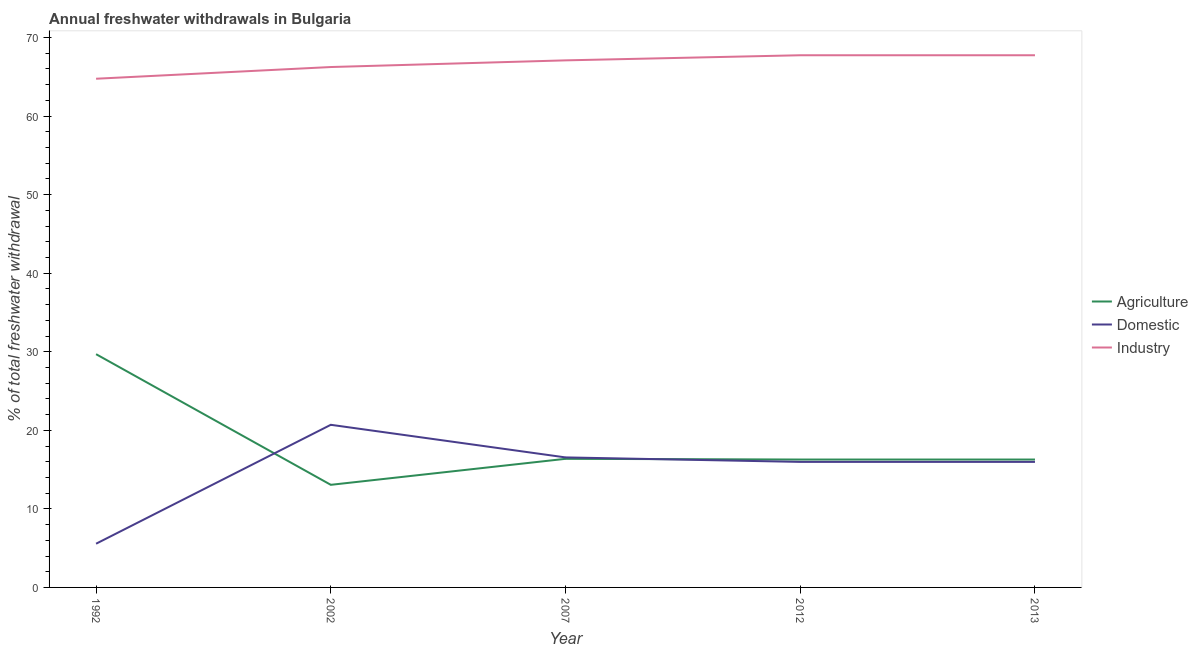How many different coloured lines are there?
Offer a terse response. 3. What is the percentage of freshwater withdrawal for industry in 2013?
Your response must be concise. 67.74. Across all years, what is the maximum percentage of freshwater withdrawal for industry?
Keep it short and to the point. 67.74. Across all years, what is the minimum percentage of freshwater withdrawal for agriculture?
Give a very brief answer. 13.06. In which year was the percentage of freshwater withdrawal for agriculture maximum?
Provide a short and direct response. 1992. In which year was the percentage of freshwater withdrawal for industry minimum?
Your response must be concise. 1992. What is the total percentage of freshwater withdrawal for industry in the graph?
Provide a short and direct response. 333.56. What is the difference between the percentage of freshwater withdrawal for agriculture in 1992 and that in 2002?
Provide a succinct answer. 16.63. What is the difference between the percentage of freshwater withdrawal for industry in 2013 and the percentage of freshwater withdrawal for domestic purposes in 2007?
Your answer should be very brief. 51.19. What is the average percentage of freshwater withdrawal for domestic purposes per year?
Provide a succinct answer. 14.95. In the year 2012, what is the difference between the percentage of freshwater withdrawal for industry and percentage of freshwater withdrawal for domestic purposes?
Make the answer very short. 51.76. In how many years, is the percentage of freshwater withdrawal for domestic purposes greater than 32 %?
Offer a very short reply. 0. What is the ratio of the percentage of freshwater withdrawal for industry in 2007 to that in 2012?
Your response must be concise. 0.99. Is the percentage of freshwater withdrawal for domestic purposes in 2007 less than that in 2013?
Your answer should be very brief. No. Is the difference between the percentage of freshwater withdrawal for industry in 2002 and 2012 greater than the difference between the percentage of freshwater withdrawal for domestic purposes in 2002 and 2012?
Your response must be concise. No. What is the difference between the highest and the second highest percentage of freshwater withdrawal for industry?
Offer a very short reply. 0. What is the difference between the highest and the lowest percentage of freshwater withdrawal for agriculture?
Make the answer very short. 16.63. Is it the case that in every year, the sum of the percentage of freshwater withdrawal for agriculture and percentage of freshwater withdrawal for domestic purposes is greater than the percentage of freshwater withdrawal for industry?
Offer a terse response. No. Is the percentage of freshwater withdrawal for industry strictly less than the percentage of freshwater withdrawal for agriculture over the years?
Make the answer very short. No. How many lines are there?
Your answer should be very brief. 3. How many years are there in the graph?
Your answer should be very brief. 5. What is the difference between two consecutive major ticks on the Y-axis?
Offer a very short reply. 10. How many legend labels are there?
Provide a succinct answer. 3. What is the title of the graph?
Make the answer very short. Annual freshwater withdrawals in Bulgaria. What is the label or title of the Y-axis?
Make the answer very short. % of total freshwater withdrawal. What is the % of total freshwater withdrawal in Agriculture in 1992?
Provide a succinct answer. 29.69. What is the % of total freshwater withdrawal in Domestic in 1992?
Provide a short and direct response. 5.56. What is the % of total freshwater withdrawal in Industry in 1992?
Ensure brevity in your answer.  64.75. What is the % of total freshwater withdrawal in Agriculture in 2002?
Your answer should be very brief. 13.06. What is the % of total freshwater withdrawal in Domestic in 2002?
Give a very brief answer. 20.7. What is the % of total freshwater withdrawal of Industry in 2002?
Offer a terse response. 66.24. What is the % of total freshwater withdrawal of Agriculture in 2007?
Keep it short and to the point. 16.37. What is the % of total freshwater withdrawal of Domestic in 2007?
Provide a succinct answer. 16.55. What is the % of total freshwater withdrawal of Industry in 2007?
Your answer should be very brief. 67.09. What is the % of total freshwater withdrawal in Agriculture in 2012?
Keep it short and to the point. 16.28. What is the % of total freshwater withdrawal in Domestic in 2012?
Your answer should be compact. 15.98. What is the % of total freshwater withdrawal in Industry in 2012?
Give a very brief answer. 67.74. What is the % of total freshwater withdrawal in Agriculture in 2013?
Your answer should be compact. 16.28. What is the % of total freshwater withdrawal in Domestic in 2013?
Provide a succinct answer. 15.98. What is the % of total freshwater withdrawal in Industry in 2013?
Give a very brief answer. 67.74. Across all years, what is the maximum % of total freshwater withdrawal of Agriculture?
Your response must be concise. 29.69. Across all years, what is the maximum % of total freshwater withdrawal of Domestic?
Provide a succinct answer. 20.7. Across all years, what is the maximum % of total freshwater withdrawal in Industry?
Your response must be concise. 67.74. Across all years, what is the minimum % of total freshwater withdrawal of Agriculture?
Offer a terse response. 13.06. Across all years, what is the minimum % of total freshwater withdrawal of Domestic?
Your answer should be very brief. 5.56. Across all years, what is the minimum % of total freshwater withdrawal in Industry?
Give a very brief answer. 64.75. What is the total % of total freshwater withdrawal in Agriculture in the graph?
Offer a very short reply. 91.68. What is the total % of total freshwater withdrawal of Domestic in the graph?
Ensure brevity in your answer.  74.77. What is the total % of total freshwater withdrawal in Industry in the graph?
Give a very brief answer. 333.56. What is the difference between the % of total freshwater withdrawal of Agriculture in 1992 and that in 2002?
Ensure brevity in your answer.  16.63. What is the difference between the % of total freshwater withdrawal of Domestic in 1992 and that in 2002?
Keep it short and to the point. -15.14. What is the difference between the % of total freshwater withdrawal in Industry in 1992 and that in 2002?
Offer a terse response. -1.49. What is the difference between the % of total freshwater withdrawal of Agriculture in 1992 and that in 2007?
Keep it short and to the point. 13.32. What is the difference between the % of total freshwater withdrawal in Domestic in 1992 and that in 2007?
Your response must be concise. -10.99. What is the difference between the % of total freshwater withdrawal of Industry in 1992 and that in 2007?
Ensure brevity in your answer.  -2.34. What is the difference between the % of total freshwater withdrawal of Agriculture in 1992 and that in 2012?
Your response must be concise. 13.41. What is the difference between the % of total freshwater withdrawal in Domestic in 1992 and that in 2012?
Offer a very short reply. -10.42. What is the difference between the % of total freshwater withdrawal in Industry in 1992 and that in 2012?
Keep it short and to the point. -2.99. What is the difference between the % of total freshwater withdrawal in Agriculture in 1992 and that in 2013?
Ensure brevity in your answer.  13.41. What is the difference between the % of total freshwater withdrawal of Domestic in 1992 and that in 2013?
Your response must be concise. -10.42. What is the difference between the % of total freshwater withdrawal in Industry in 1992 and that in 2013?
Provide a succinct answer. -2.99. What is the difference between the % of total freshwater withdrawal in Agriculture in 2002 and that in 2007?
Provide a succinct answer. -3.31. What is the difference between the % of total freshwater withdrawal of Domestic in 2002 and that in 2007?
Ensure brevity in your answer.  4.15. What is the difference between the % of total freshwater withdrawal of Industry in 2002 and that in 2007?
Offer a very short reply. -0.85. What is the difference between the % of total freshwater withdrawal in Agriculture in 2002 and that in 2012?
Provide a short and direct response. -3.22. What is the difference between the % of total freshwater withdrawal of Domestic in 2002 and that in 2012?
Your response must be concise. 4.72. What is the difference between the % of total freshwater withdrawal of Industry in 2002 and that in 2012?
Your response must be concise. -1.5. What is the difference between the % of total freshwater withdrawal in Agriculture in 2002 and that in 2013?
Your answer should be very brief. -3.22. What is the difference between the % of total freshwater withdrawal of Domestic in 2002 and that in 2013?
Your answer should be compact. 4.72. What is the difference between the % of total freshwater withdrawal in Agriculture in 2007 and that in 2012?
Make the answer very short. 0.09. What is the difference between the % of total freshwater withdrawal of Domestic in 2007 and that in 2012?
Make the answer very short. 0.57. What is the difference between the % of total freshwater withdrawal of Industry in 2007 and that in 2012?
Provide a succinct answer. -0.65. What is the difference between the % of total freshwater withdrawal in Agriculture in 2007 and that in 2013?
Make the answer very short. 0.09. What is the difference between the % of total freshwater withdrawal of Domestic in 2007 and that in 2013?
Keep it short and to the point. 0.57. What is the difference between the % of total freshwater withdrawal of Industry in 2007 and that in 2013?
Your answer should be compact. -0.65. What is the difference between the % of total freshwater withdrawal in Agriculture in 1992 and the % of total freshwater withdrawal in Domestic in 2002?
Keep it short and to the point. 8.99. What is the difference between the % of total freshwater withdrawal of Agriculture in 1992 and the % of total freshwater withdrawal of Industry in 2002?
Your response must be concise. -36.55. What is the difference between the % of total freshwater withdrawal in Domestic in 1992 and the % of total freshwater withdrawal in Industry in 2002?
Keep it short and to the point. -60.68. What is the difference between the % of total freshwater withdrawal of Agriculture in 1992 and the % of total freshwater withdrawal of Domestic in 2007?
Provide a succinct answer. 13.14. What is the difference between the % of total freshwater withdrawal in Agriculture in 1992 and the % of total freshwater withdrawal in Industry in 2007?
Make the answer very short. -37.4. What is the difference between the % of total freshwater withdrawal in Domestic in 1992 and the % of total freshwater withdrawal in Industry in 2007?
Your answer should be compact. -61.53. What is the difference between the % of total freshwater withdrawal in Agriculture in 1992 and the % of total freshwater withdrawal in Domestic in 2012?
Keep it short and to the point. 13.71. What is the difference between the % of total freshwater withdrawal of Agriculture in 1992 and the % of total freshwater withdrawal of Industry in 2012?
Provide a short and direct response. -38.05. What is the difference between the % of total freshwater withdrawal of Domestic in 1992 and the % of total freshwater withdrawal of Industry in 2012?
Give a very brief answer. -62.18. What is the difference between the % of total freshwater withdrawal in Agriculture in 1992 and the % of total freshwater withdrawal in Domestic in 2013?
Make the answer very short. 13.71. What is the difference between the % of total freshwater withdrawal in Agriculture in 1992 and the % of total freshwater withdrawal in Industry in 2013?
Offer a very short reply. -38.05. What is the difference between the % of total freshwater withdrawal of Domestic in 1992 and the % of total freshwater withdrawal of Industry in 2013?
Provide a short and direct response. -62.18. What is the difference between the % of total freshwater withdrawal in Agriculture in 2002 and the % of total freshwater withdrawal in Domestic in 2007?
Your response must be concise. -3.49. What is the difference between the % of total freshwater withdrawal of Agriculture in 2002 and the % of total freshwater withdrawal of Industry in 2007?
Offer a terse response. -54.03. What is the difference between the % of total freshwater withdrawal in Domestic in 2002 and the % of total freshwater withdrawal in Industry in 2007?
Give a very brief answer. -46.39. What is the difference between the % of total freshwater withdrawal in Agriculture in 2002 and the % of total freshwater withdrawal in Domestic in 2012?
Provide a short and direct response. -2.92. What is the difference between the % of total freshwater withdrawal in Agriculture in 2002 and the % of total freshwater withdrawal in Industry in 2012?
Ensure brevity in your answer.  -54.68. What is the difference between the % of total freshwater withdrawal in Domestic in 2002 and the % of total freshwater withdrawal in Industry in 2012?
Keep it short and to the point. -47.04. What is the difference between the % of total freshwater withdrawal of Agriculture in 2002 and the % of total freshwater withdrawal of Domestic in 2013?
Make the answer very short. -2.92. What is the difference between the % of total freshwater withdrawal of Agriculture in 2002 and the % of total freshwater withdrawal of Industry in 2013?
Offer a terse response. -54.68. What is the difference between the % of total freshwater withdrawal of Domestic in 2002 and the % of total freshwater withdrawal of Industry in 2013?
Make the answer very short. -47.04. What is the difference between the % of total freshwater withdrawal in Agriculture in 2007 and the % of total freshwater withdrawal in Domestic in 2012?
Provide a succinct answer. 0.39. What is the difference between the % of total freshwater withdrawal in Agriculture in 2007 and the % of total freshwater withdrawal in Industry in 2012?
Provide a short and direct response. -51.37. What is the difference between the % of total freshwater withdrawal of Domestic in 2007 and the % of total freshwater withdrawal of Industry in 2012?
Provide a succinct answer. -51.19. What is the difference between the % of total freshwater withdrawal of Agriculture in 2007 and the % of total freshwater withdrawal of Domestic in 2013?
Give a very brief answer. 0.39. What is the difference between the % of total freshwater withdrawal of Agriculture in 2007 and the % of total freshwater withdrawal of Industry in 2013?
Your answer should be very brief. -51.37. What is the difference between the % of total freshwater withdrawal of Domestic in 2007 and the % of total freshwater withdrawal of Industry in 2013?
Offer a very short reply. -51.19. What is the difference between the % of total freshwater withdrawal in Agriculture in 2012 and the % of total freshwater withdrawal in Industry in 2013?
Provide a succinct answer. -51.46. What is the difference between the % of total freshwater withdrawal in Domestic in 2012 and the % of total freshwater withdrawal in Industry in 2013?
Offer a very short reply. -51.76. What is the average % of total freshwater withdrawal of Agriculture per year?
Provide a short and direct response. 18.34. What is the average % of total freshwater withdrawal of Domestic per year?
Ensure brevity in your answer.  14.95. What is the average % of total freshwater withdrawal in Industry per year?
Provide a short and direct response. 66.71. In the year 1992, what is the difference between the % of total freshwater withdrawal of Agriculture and % of total freshwater withdrawal of Domestic?
Give a very brief answer. 24.13. In the year 1992, what is the difference between the % of total freshwater withdrawal of Agriculture and % of total freshwater withdrawal of Industry?
Keep it short and to the point. -35.06. In the year 1992, what is the difference between the % of total freshwater withdrawal of Domestic and % of total freshwater withdrawal of Industry?
Your answer should be very brief. -59.19. In the year 2002, what is the difference between the % of total freshwater withdrawal of Agriculture and % of total freshwater withdrawal of Domestic?
Your response must be concise. -7.64. In the year 2002, what is the difference between the % of total freshwater withdrawal in Agriculture and % of total freshwater withdrawal in Industry?
Your answer should be very brief. -53.18. In the year 2002, what is the difference between the % of total freshwater withdrawal of Domestic and % of total freshwater withdrawal of Industry?
Keep it short and to the point. -45.54. In the year 2007, what is the difference between the % of total freshwater withdrawal of Agriculture and % of total freshwater withdrawal of Domestic?
Provide a succinct answer. -0.18. In the year 2007, what is the difference between the % of total freshwater withdrawal of Agriculture and % of total freshwater withdrawal of Industry?
Keep it short and to the point. -50.72. In the year 2007, what is the difference between the % of total freshwater withdrawal in Domestic and % of total freshwater withdrawal in Industry?
Keep it short and to the point. -50.54. In the year 2012, what is the difference between the % of total freshwater withdrawal in Agriculture and % of total freshwater withdrawal in Industry?
Keep it short and to the point. -51.46. In the year 2012, what is the difference between the % of total freshwater withdrawal in Domestic and % of total freshwater withdrawal in Industry?
Provide a short and direct response. -51.76. In the year 2013, what is the difference between the % of total freshwater withdrawal in Agriculture and % of total freshwater withdrawal in Domestic?
Your answer should be compact. 0.3. In the year 2013, what is the difference between the % of total freshwater withdrawal of Agriculture and % of total freshwater withdrawal of Industry?
Your response must be concise. -51.46. In the year 2013, what is the difference between the % of total freshwater withdrawal in Domestic and % of total freshwater withdrawal in Industry?
Provide a short and direct response. -51.76. What is the ratio of the % of total freshwater withdrawal in Agriculture in 1992 to that in 2002?
Ensure brevity in your answer.  2.27. What is the ratio of the % of total freshwater withdrawal of Domestic in 1992 to that in 2002?
Keep it short and to the point. 0.27. What is the ratio of the % of total freshwater withdrawal of Industry in 1992 to that in 2002?
Make the answer very short. 0.98. What is the ratio of the % of total freshwater withdrawal in Agriculture in 1992 to that in 2007?
Provide a short and direct response. 1.81. What is the ratio of the % of total freshwater withdrawal in Domestic in 1992 to that in 2007?
Keep it short and to the point. 0.34. What is the ratio of the % of total freshwater withdrawal in Industry in 1992 to that in 2007?
Make the answer very short. 0.97. What is the ratio of the % of total freshwater withdrawal in Agriculture in 1992 to that in 2012?
Ensure brevity in your answer.  1.82. What is the ratio of the % of total freshwater withdrawal of Domestic in 1992 to that in 2012?
Give a very brief answer. 0.35. What is the ratio of the % of total freshwater withdrawal of Industry in 1992 to that in 2012?
Offer a terse response. 0.96. What is the ratio of the % of total freshwater withdrawal in Agriculture in 1992 to that in 2013?
Make the answer very short. 1.82. What is the ratio of the % of total freshwater withdrawal of Domestic in 1992 to that in 2013?
Your answer should be compact. 0.35. What is the ratio of the % of total freshwater withdrawal in Industry in 1992 to that in 2013?
Provide a short and direct response. 0.96. What is the ratio of the % of total freshwater withdrawal in Agriculture in 2002 to that in 2007?
Make the answer very short. 0.8. What is the ratio of the % of total freshwater withdrawal in Domestic in 2002 to that in 2007?
Offer a terse response. 1.25. What is the ratio of the % of total freshwater withdrawal of Industry in 2002 to that in 2007?
Offer a very short reply. 0.99. What is the ratio of the % of total freshwater withdrawal in Agriculture in 2002 to that in 2012?
Keep it short and to the point. 0.8. What is the ratio of the % of total freshwater withdrawal in Domestic in 2002 to that in 2012?
Provide a short and direct response. 1.3. What is the ratio of the % of total freshwater withdrawal of Industry in 2002 to that in 2012?
Offer a very short reply. 0.98. What is the ratio of the % of total freshwater withdrawal in Agriculture in 2002 to that in 2013?
Keep it short and to the point. 0.8. What is the ratio of the % of total freshwater withdrawal in Domestic in 2002 to that in 2013?
Your response must be concise. 1.3. What is the ratio of the % of total freshwater withdrawal of Industry in 2002 to that in 2013?
Your response must be concise. 0.98. What is the ratio of the % of total freshwater withdrawal of Domestic in 2007 to that in 2012?
Your response must be concise. 1.04. What is the ratio of the % of total freshwater withdrawal of Agriculture in 2007 to that in 2013?
Your response must be concise. 1.01. What is the ratio of the % of total freshwater withdrawal of Domestic in 2007 to that in 2013?
Your answer should be compact. 1.04. What is the ratio of the % of total freshwater withdrawal of Domestic in 2012 to that in 2013?
Offer a very short reply. 1. What is the difference between the highest and the second highest % of total freshwater withdrawal in Agriculture?
Your answer should be very brief. 13.32. What is the difference between the highest and the second highest % of total freshwater withdrawal of Domestic?
Make the answer very short. 4.15. What is the difference between the highest and the second highest % of total freshwater withdrawal in Industry?
Keep it short and to the point. 0. What is the difference between the highest and the lowest % of total freshwater withdrawal of Agriculture?
Keep it short and to the point. 16.63. What is the difference between the highest and the lowest % of total freshwater withdrawal of Domestic?
Provide a short and direct response. 15.14. What is the difference between the highest and the lowest % of total freshwater withdrawal of Industry?
Keep it short and to the point. 2.99. 